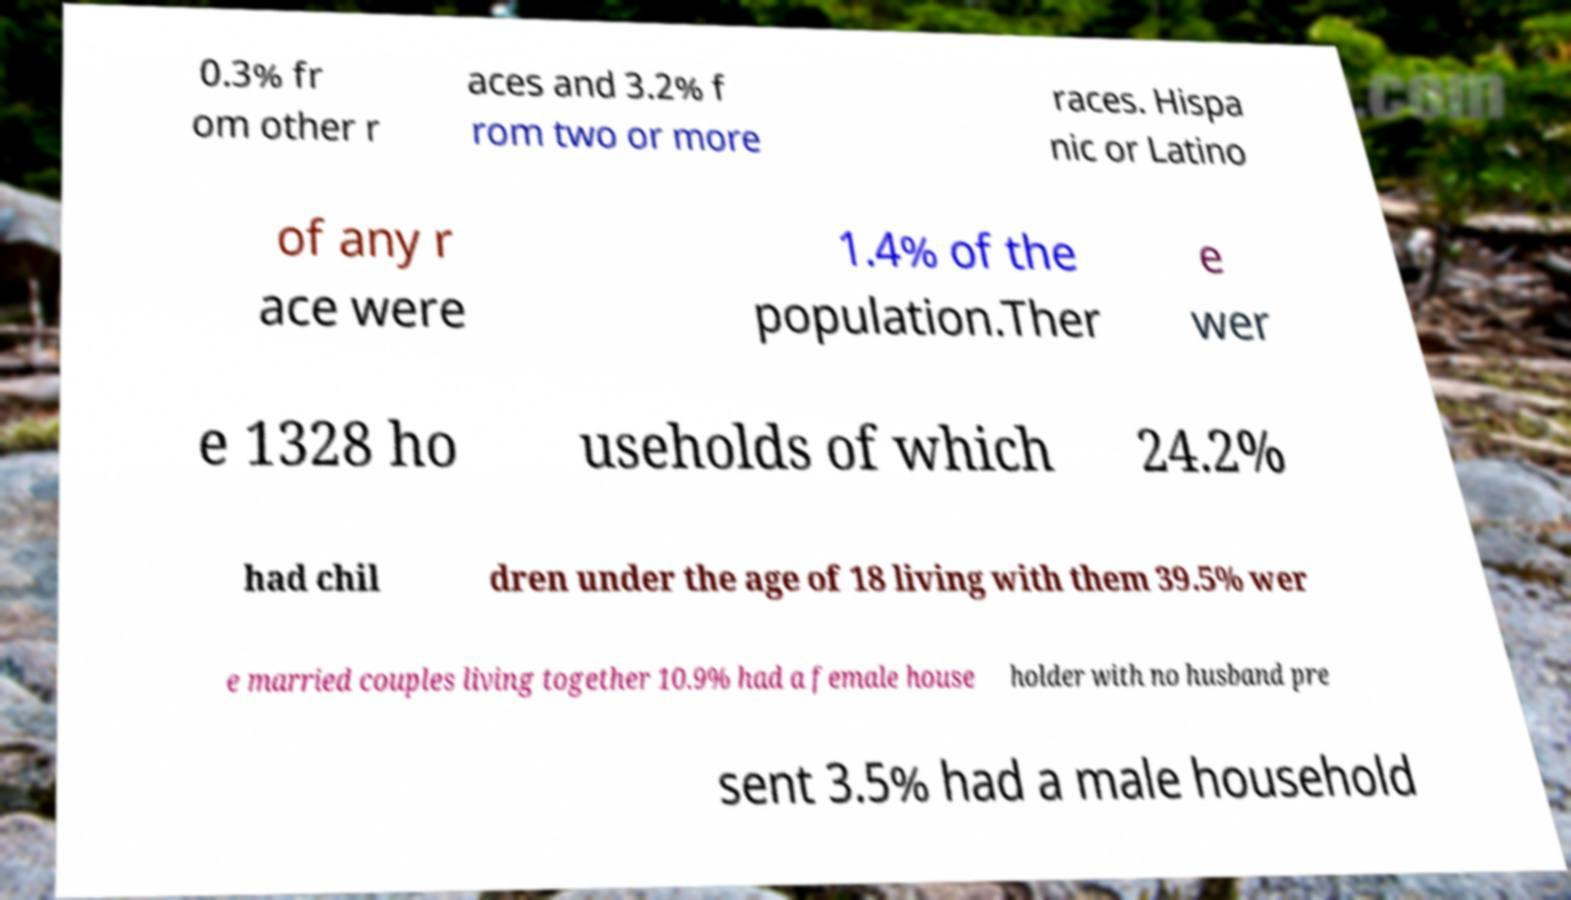Please read and relay the text visible in this image. What does it say? 0.3% fr om other r aces and 3.2% f rom two or more races. Hispa nic or Latino of any r ace were 1.4% of the population.Ther e wer e 1328 ho useholds of which 24.2% had chil dren under the age of 18 living with them 39.5% wer e married couples living together 10.9% had a female house holder with no husband pre sent 3.5% had a male household 